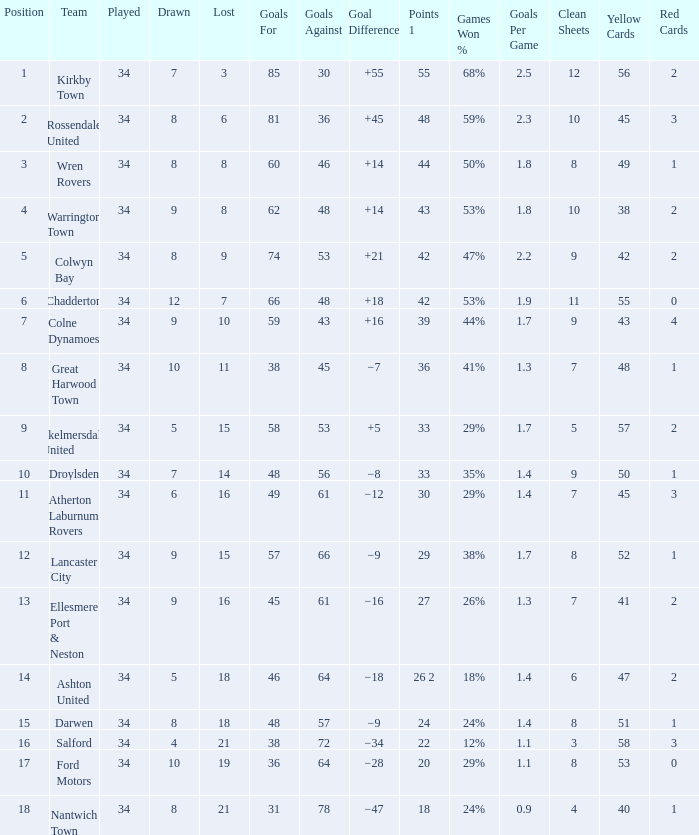What is the smallest number of goals against when there are 1 of 18 points, and more than 8 are drawn? None. 